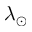Convert formula to latex. <formula><loc_0><loc_0><loc_500><loc_500>\lambda _ { \odot }</formula> 